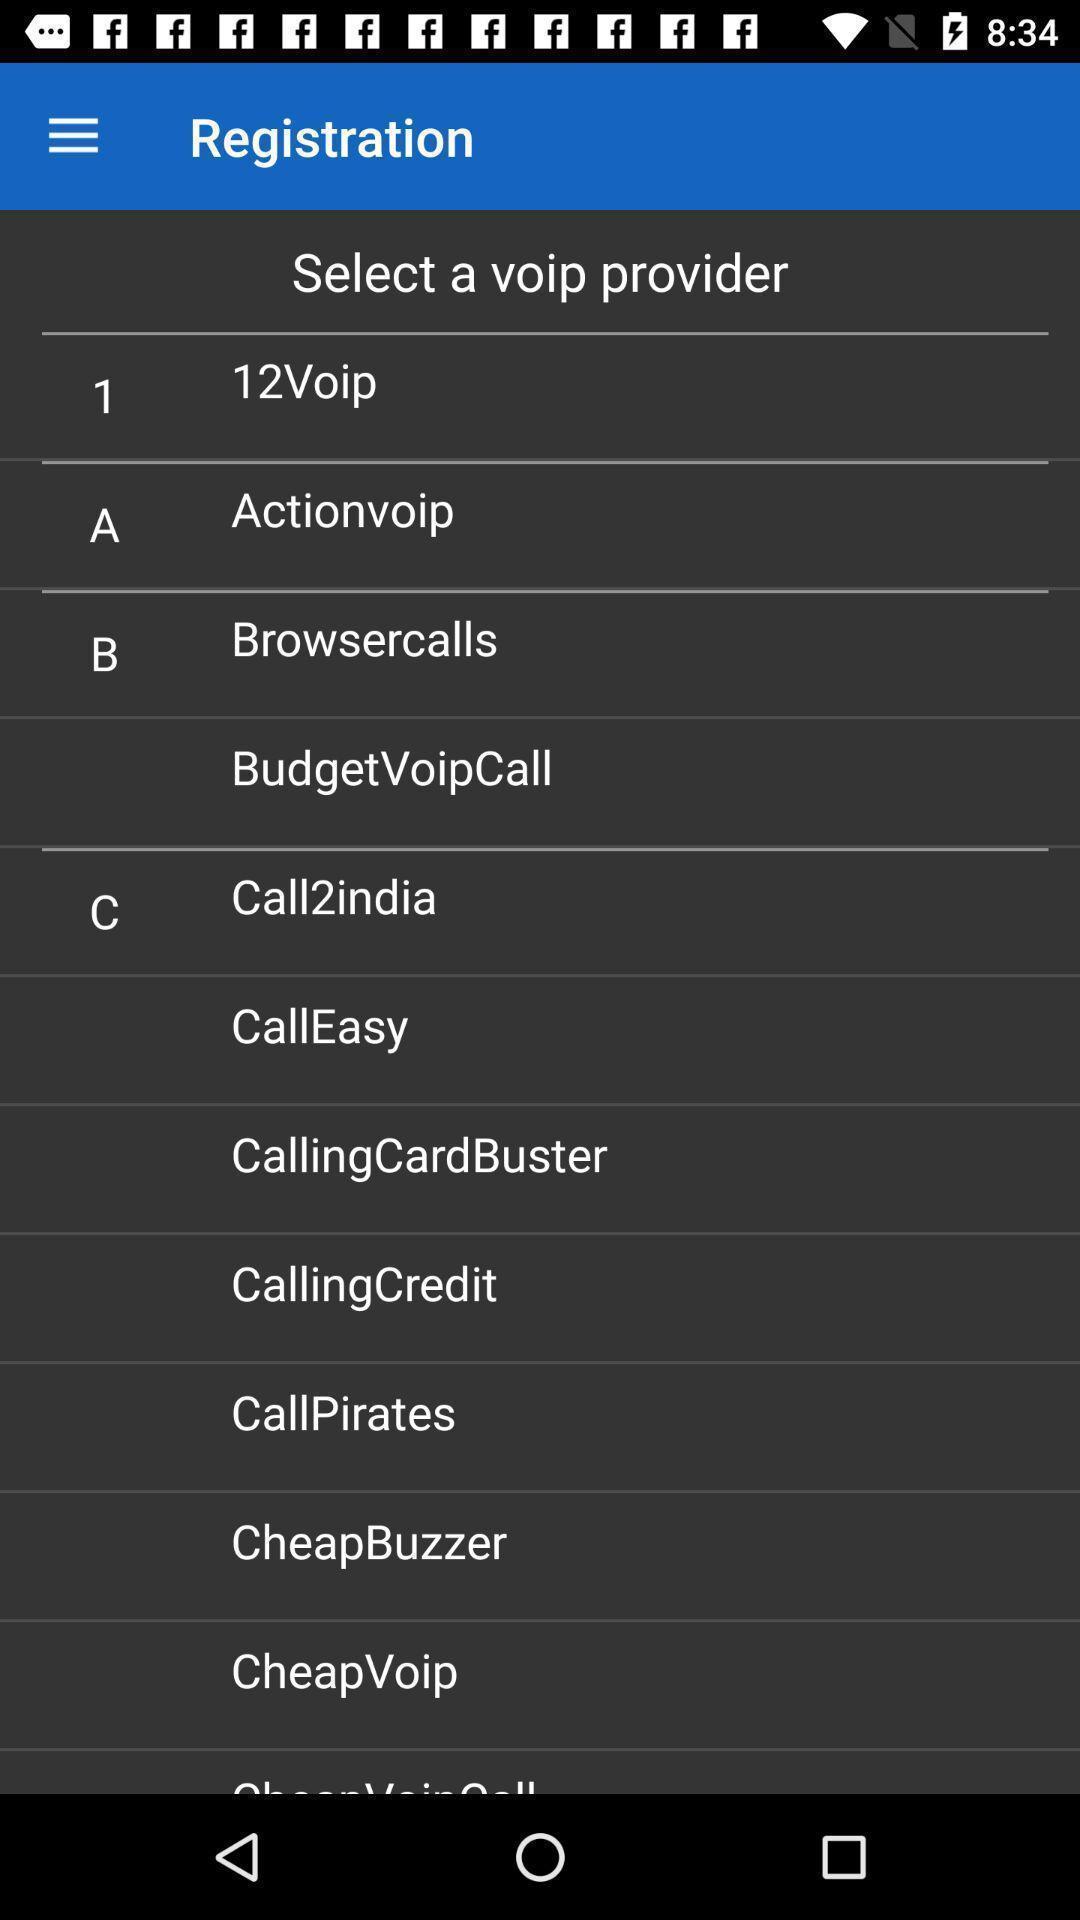Describe the content in this image. Page showing different registration provider list for ip telephony app. 